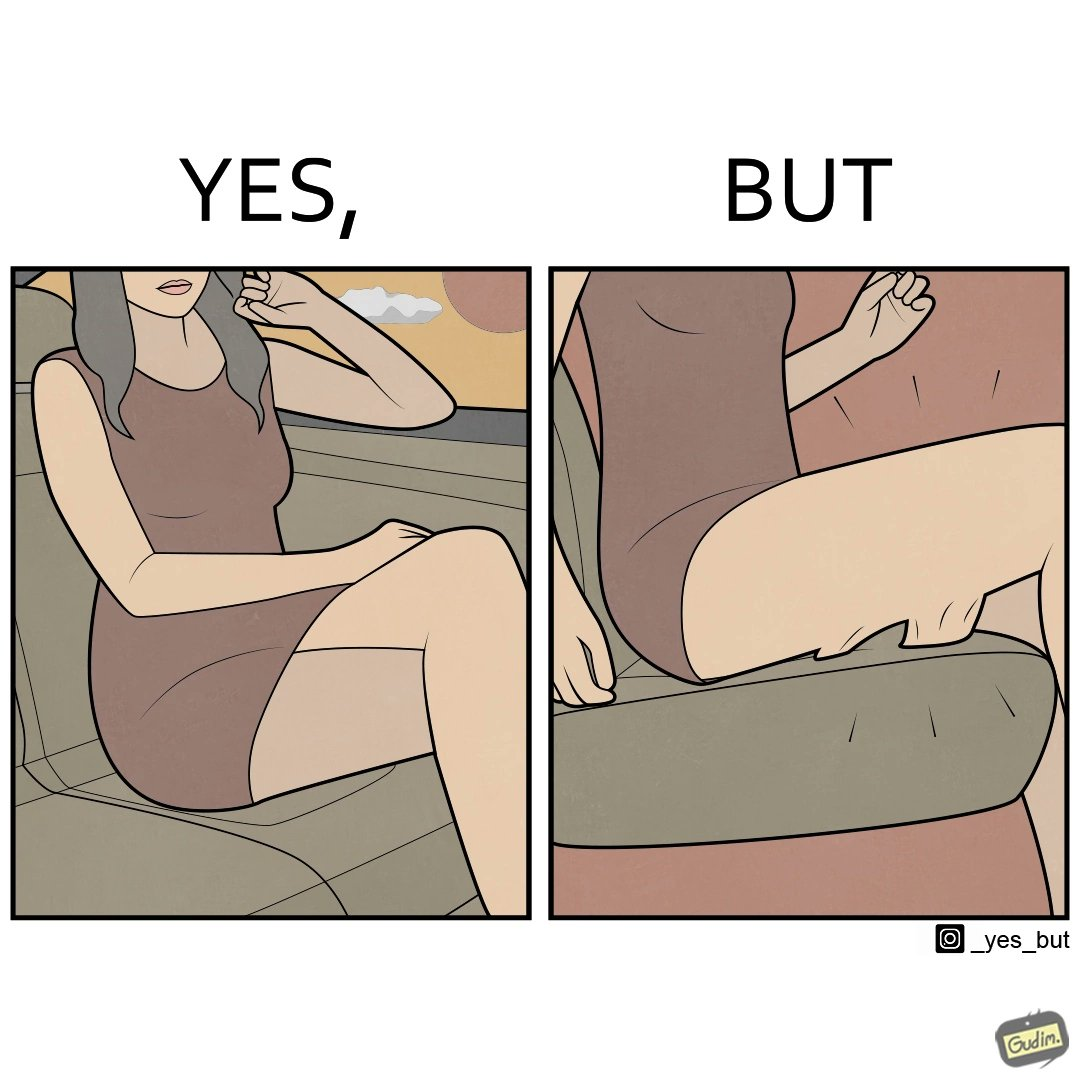Does this image contain satire or humor? Yes, this image is satirical. 